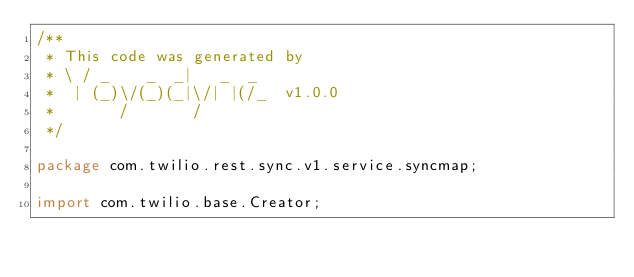<code> <loc_0><loc_0><loc_500><loc_500><_Java_>/**
 * This code was generated by
 * \ / _    _  _|   _  _
 *  | (_)\/(_)(_|\/| |(/_  v1.0.0
 *       /       /
 */

package com.twilio.rest.sync.v1.service.syncmap;

import com.twilio.base.Creator;</code> 